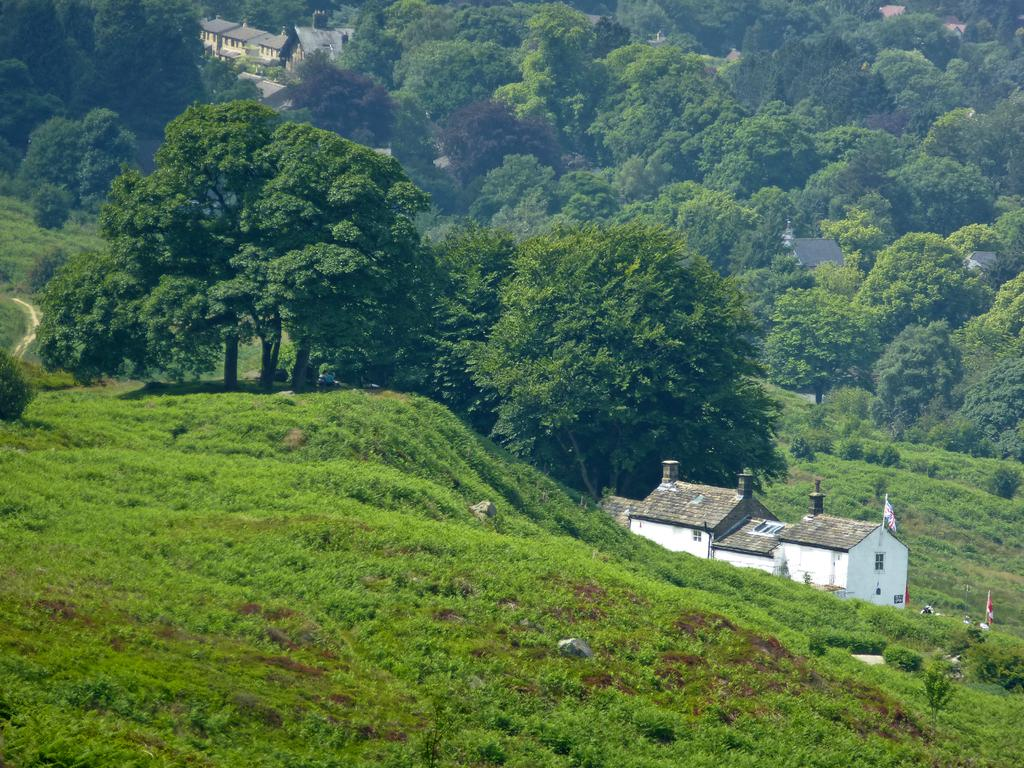What type of vegetation can be seen in the image? There is grass in the image. What are the tall, thin objects with colors and patterns in the image? There are flags in the image. What type of structures are visible in the image? There are buildings with windows in the image. What can be seen in the distance in the image? There are trees visible in the background of the image. What type of education can be seen taking place in the image? There is no indication of education taking place in the image. What noise can be heard coming from the trees in the background of the image? The image is silent, and no noise can be heard. 